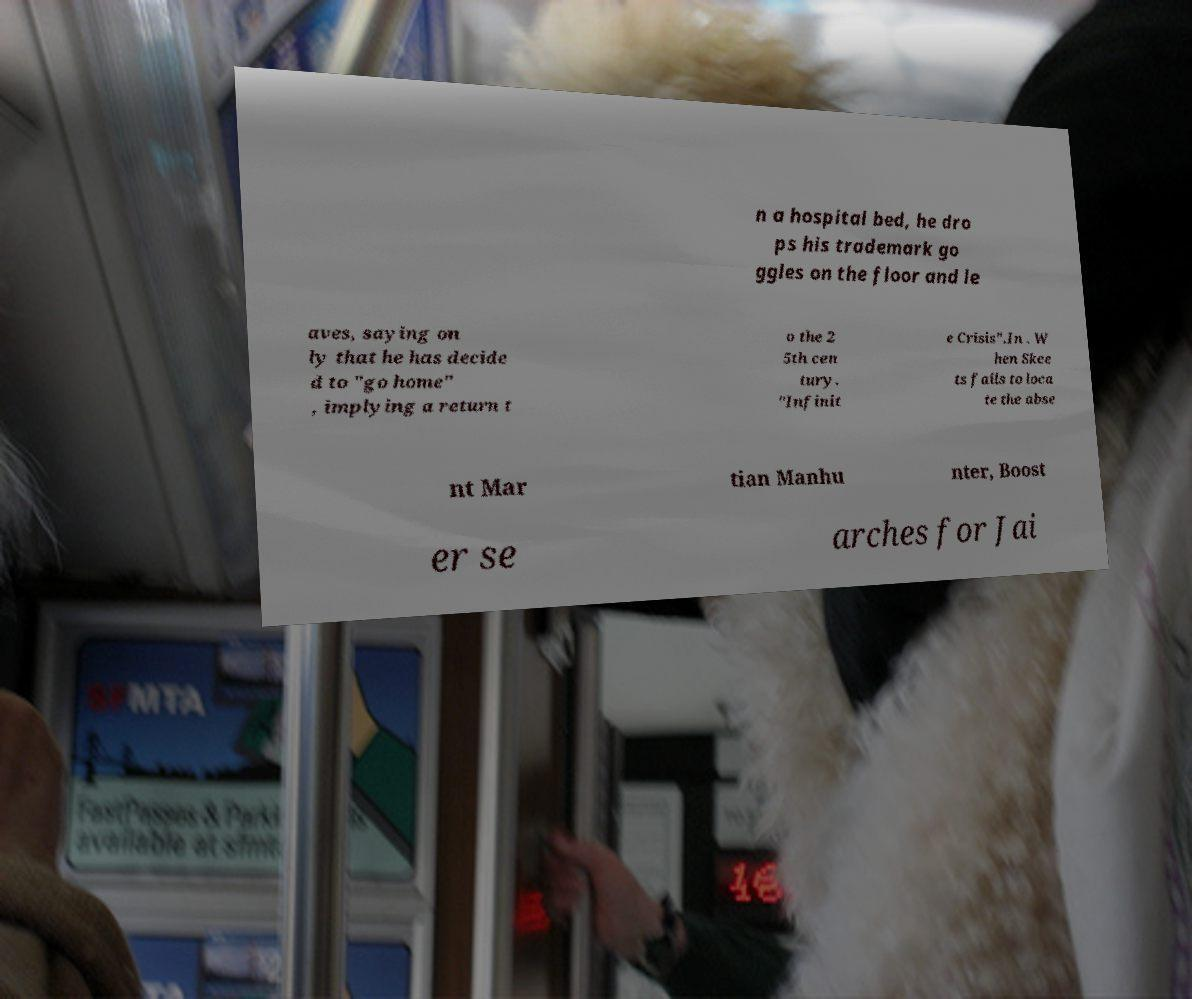There's text embedded in this image that I need extracted. Can you transcribe it verbatim? n a hospital bed, he dro ps his trademark go ggles on the floor and le aves, saying on ly that he has decide d to "go home" , implying a return t o the 2 5th cen tury. "Infinit e Crisis".In . W hen Skee ts fails to loca te the abse nt Mar tian Manhu nter, Boost er se arches for Jai 